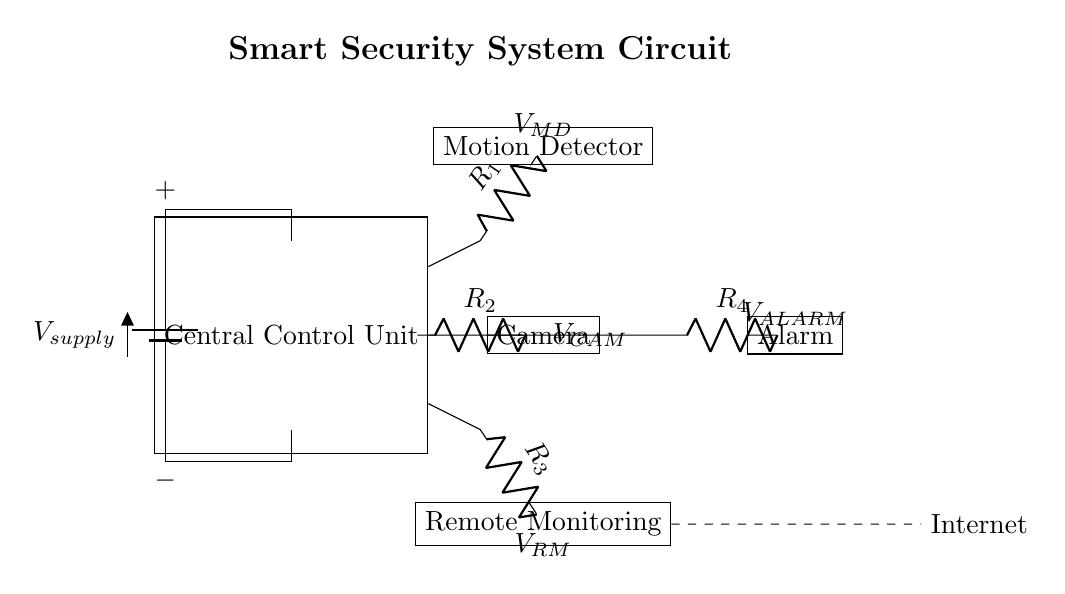What is the name of the central component? The central component is labeled as "Central Control Unit." It indicates the main processing unit of the circuit.
Answer: Central Control Unit What does V supply represent? V supply represents the voltage supplied to the circuit. It is the input voltage from the power source connected at the beginning of the circuit.
Answer: Voltage supplied Which component is connected to the camera? The camera is connected directly to the Central Control Unit, since a wire runs from the CCU to the camera.
Answer: Central Control Unit How many resistors are present in the circuit? By counting the components labeled with R, there are four distinct resistors present in the circuit diagram, each connected to a specific device.
Answer: Four Why is there an Internet connection labeled? The Internet connection is labeled to indicate that the Remote Monitoring component can send and receive data remotely over the internet. This is crucial for smart security systems to provide real-time monitoring.
Answer: Remote Monitoring What is the function of the motion detector in this circuit? The motion detector serves to sense movements and trigger alerts or notifications. It is connected to the Central Control Unit, enabling the system to respond to detected motion.
Answer: Senses movements What is the voltage across the alarm? The voltage across the alarm is indicated as V ALARM, which signifies the voltage applied to the alarm component, allowing it to function when activated by the Central Control Unit.
Answer: V ALARM 